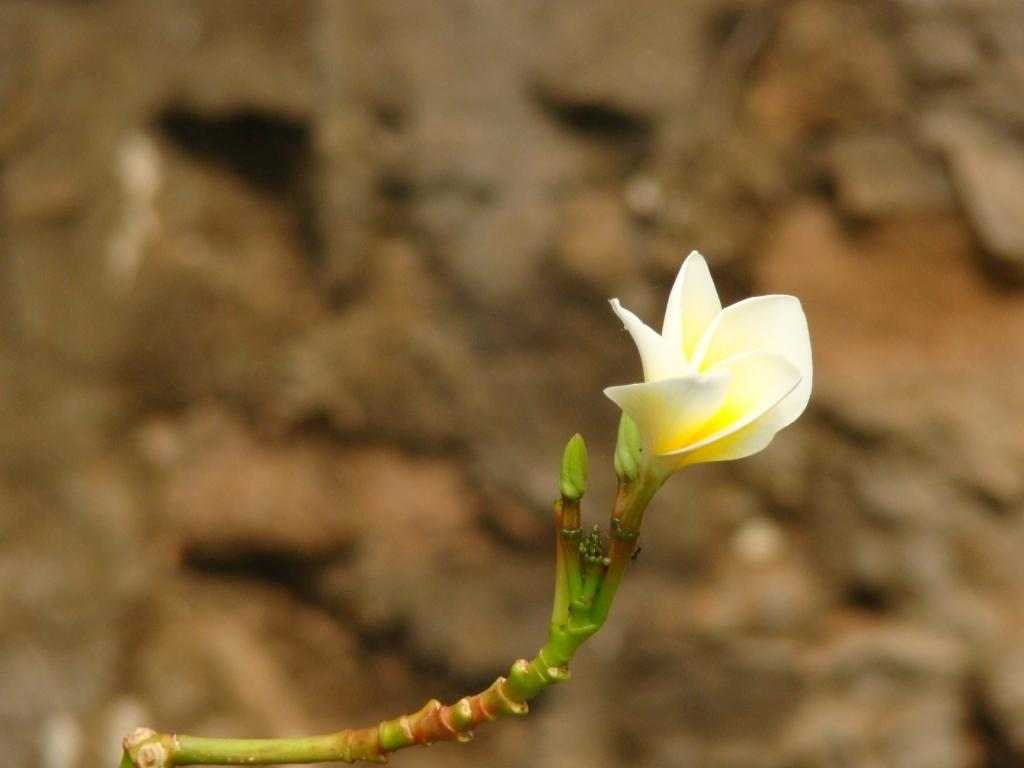What type of flower is in the picture? There is a white color flower in the picture. Can you describe the background of the image? The background of the image is blurred. Is there a boat visible in the picture? No, there is no boat present in the picture. Can you see any bones in the image? No, there are no bones visible in the image. 